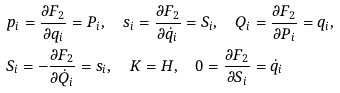<formula> <loc_0><loc_0><loc_500><loc_500>& p _ { i } = \frac { \partial F _ { 2 } } { \partial q _ { i } } = P _ { i } , \quad s _ { i } = \frac { \partial F _ { 2 } } { \partial \dot { q } _ { i } } = S _ { i } , \quad Q _ { i } = \frac { \partial F _ { 2 } } { \partial P _ { i } } = q _ { i } , \\ & S _ { i } = - \frac { \partial F _ { 2 } } { \partial \dot { Q } _ { i } } = s _ { i } , \quad K = H , \quad 0 = \frac { \partial F _ { 2 } } { \partial S _ { i } } = \dot { q } _ { i }</formula> 